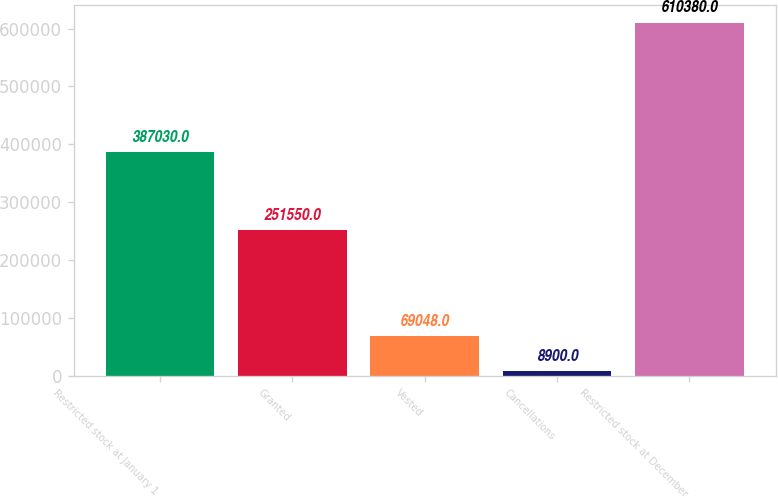<chart> <loc_0><loc_0><loc_500><loc_500><bar_chart><fcel>Restricted stock at January 1<fcel>Granted<fcel>Vested<fcel>Cancellations<fcel>Restricted stock at December<nl><fcel>387030<fcel>251550<fcel>69048<fcel>8900<fcel>610380<nl></chart> 